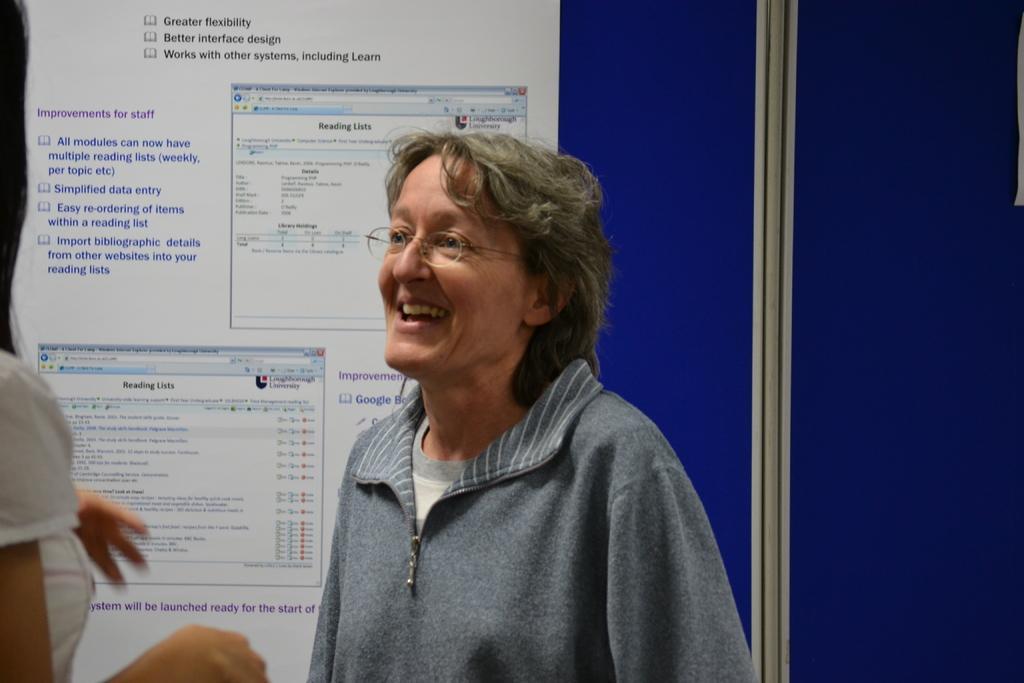Please provide a concise description of this image. In the center of the image we can see two persons are standing. And the right side person is smiling, which we can see on her face. In the background there is a screen. And we can see something written on the screen. 